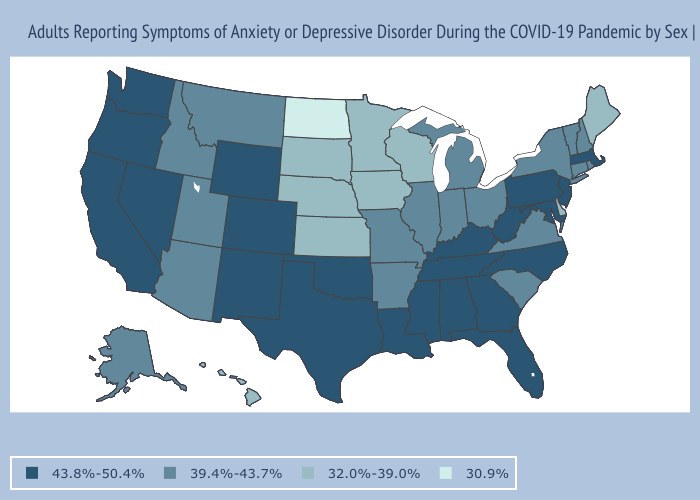Among the states that border Wyoming , which have the highest value?
Write a very short answer. Colorado. Does Maine have a lower value than Minnesota?
Concise answer only. No. Which states have the lowest value in the MidWest?
Concise answer only. North Dakota. Does the first symbol in the legend represent the smallest category?
Be succinct. No. Does Texas have the highest value in the USA?
Quick response, please. Yes. What is the value of Connecticut?
Write a very short answer. 39.4%-43.7%. What is the value of Florida?
Quick response, please. 43.8%-50.4%. Does Washington have the lowest value in the USA?
Be succinct. No. What is the value of Utah?
Concise answer only. 39.4%-43.7%. What is the lowest value in the MidWest?
Be succinct. 30.9%. Which states have the lowest value in the MidWest?
Keep it brief. North Dakota. Does Minnesota have a lower value than South Dakota?
Be succinct. No. What is the value of West Virginia?
Short answer required. 43.8%-50.4%. What is the value of New York?
Concise answer only. 39.4%-43.7%. What is the highest value in the Northeast ?
Concise answer only. 43.8%-50.4%. 